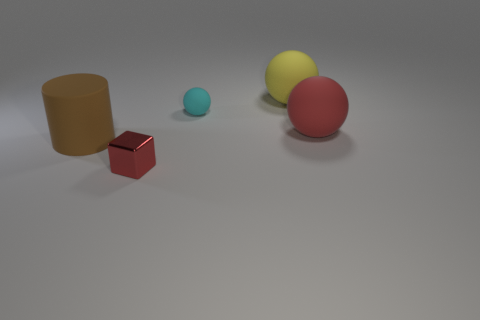The cyan thing that is made of the same material as the large cylinder is what shape?
Provide a succinct answer. Sphere. Are there any other things that have the same shape as the small metallic thing?
Your response must be concise. No. What color is the matte object that is in front of the tiny rubber object and behind the cylinder?
Offer a very short reply. Red. What number of blocks are either small yellow things or matte objects?
Keep it short and to the point. 0. What number of matte cylinders have the same size as the red sphere?
Your response must be concise. 1. What number of rubber things are behind the matte sphere behind the small rubber object?
Make the answer very short. 0. There is a object that is in front of the red ball and right of the brown rubber object; what is its size?
Provide a succinct answer. Small. Is the number of metal blocks greater than the number of tiny objects?
Keep it short and to the point. No. Is there a rubber ball of the same color as the small shiny thing?
Your answer should be compact. Yes. Does the rubber thing left of the cyan sphere have the same size as the yellow rubber object?
Offer a terse response. Yes. 